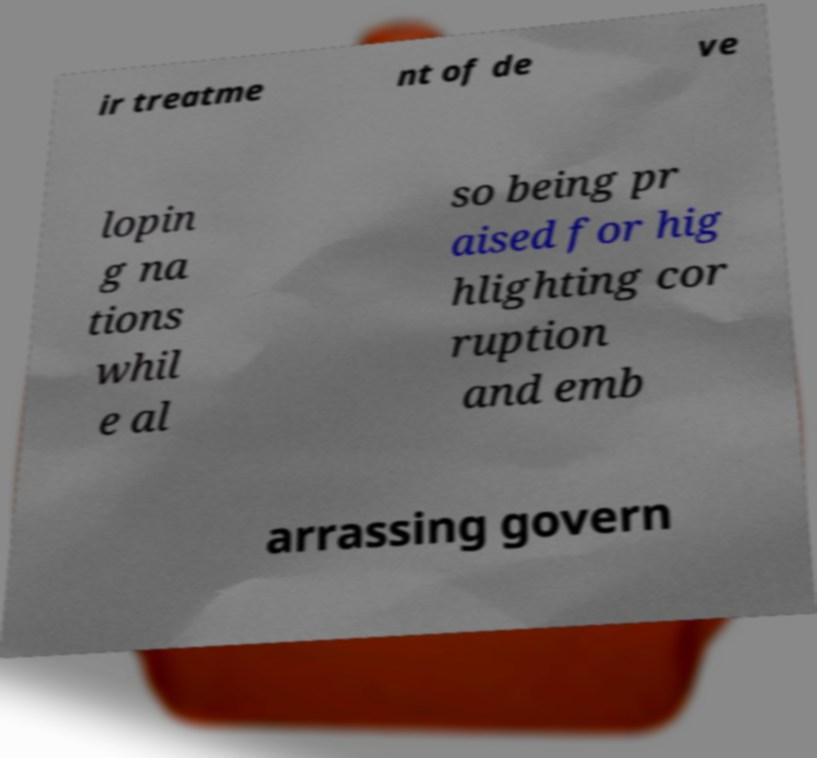I need the written content from this picture converted into text. Can you do that? ir treatme nt of de ve lopin g na tions whil e al so being pr aised for hig hlighting cor ruption and emb arrassing govern 